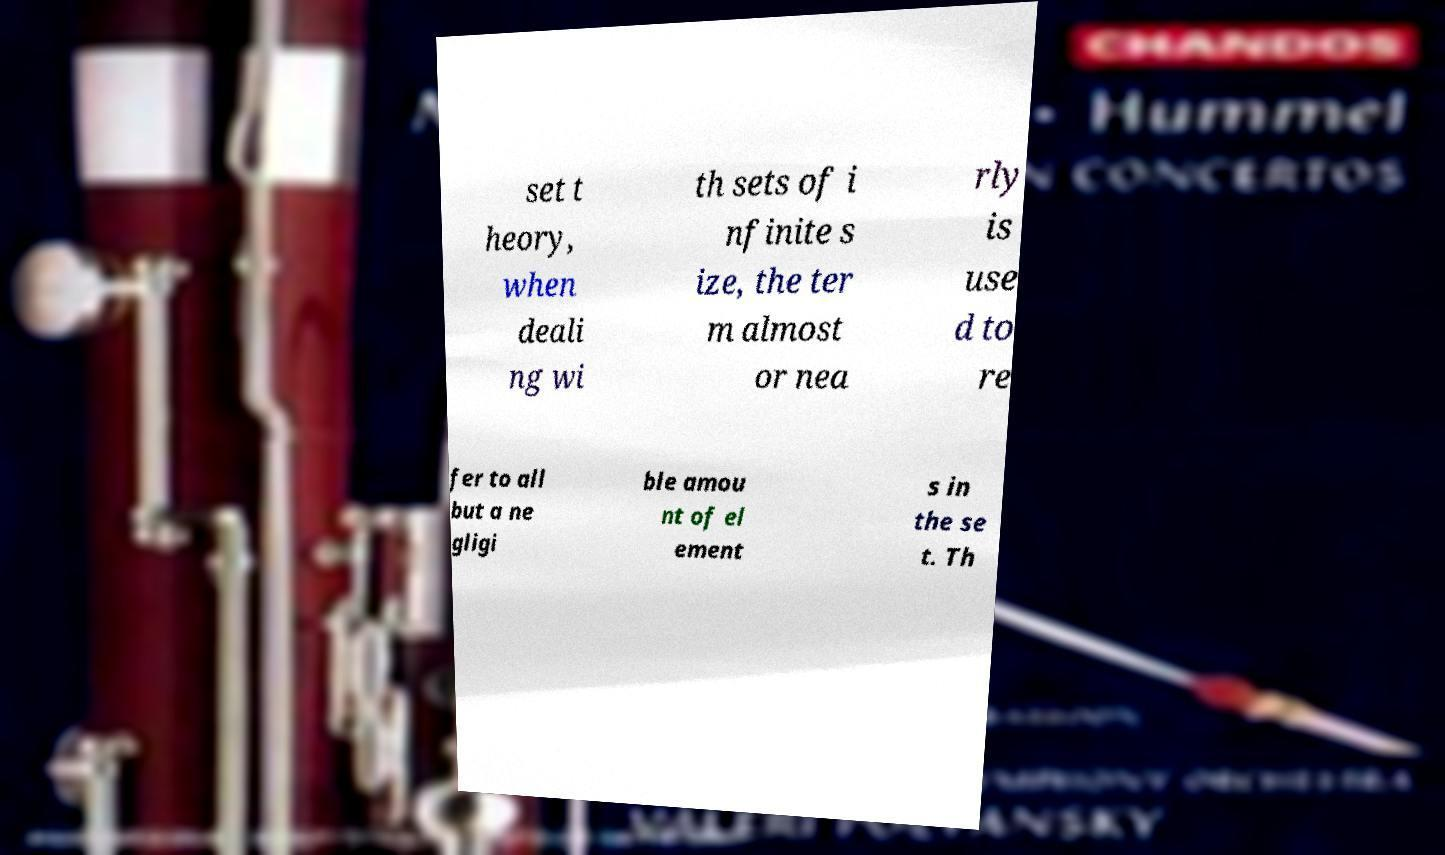I need the written content from this picture converted into text. Can you do that? set t heory, when deali ng wi th sets of i nfinite s ize, the ter m almost or nea rly is use d to re fer to all but a ne gligi ble amou nt of el ement s in the se t. Th 